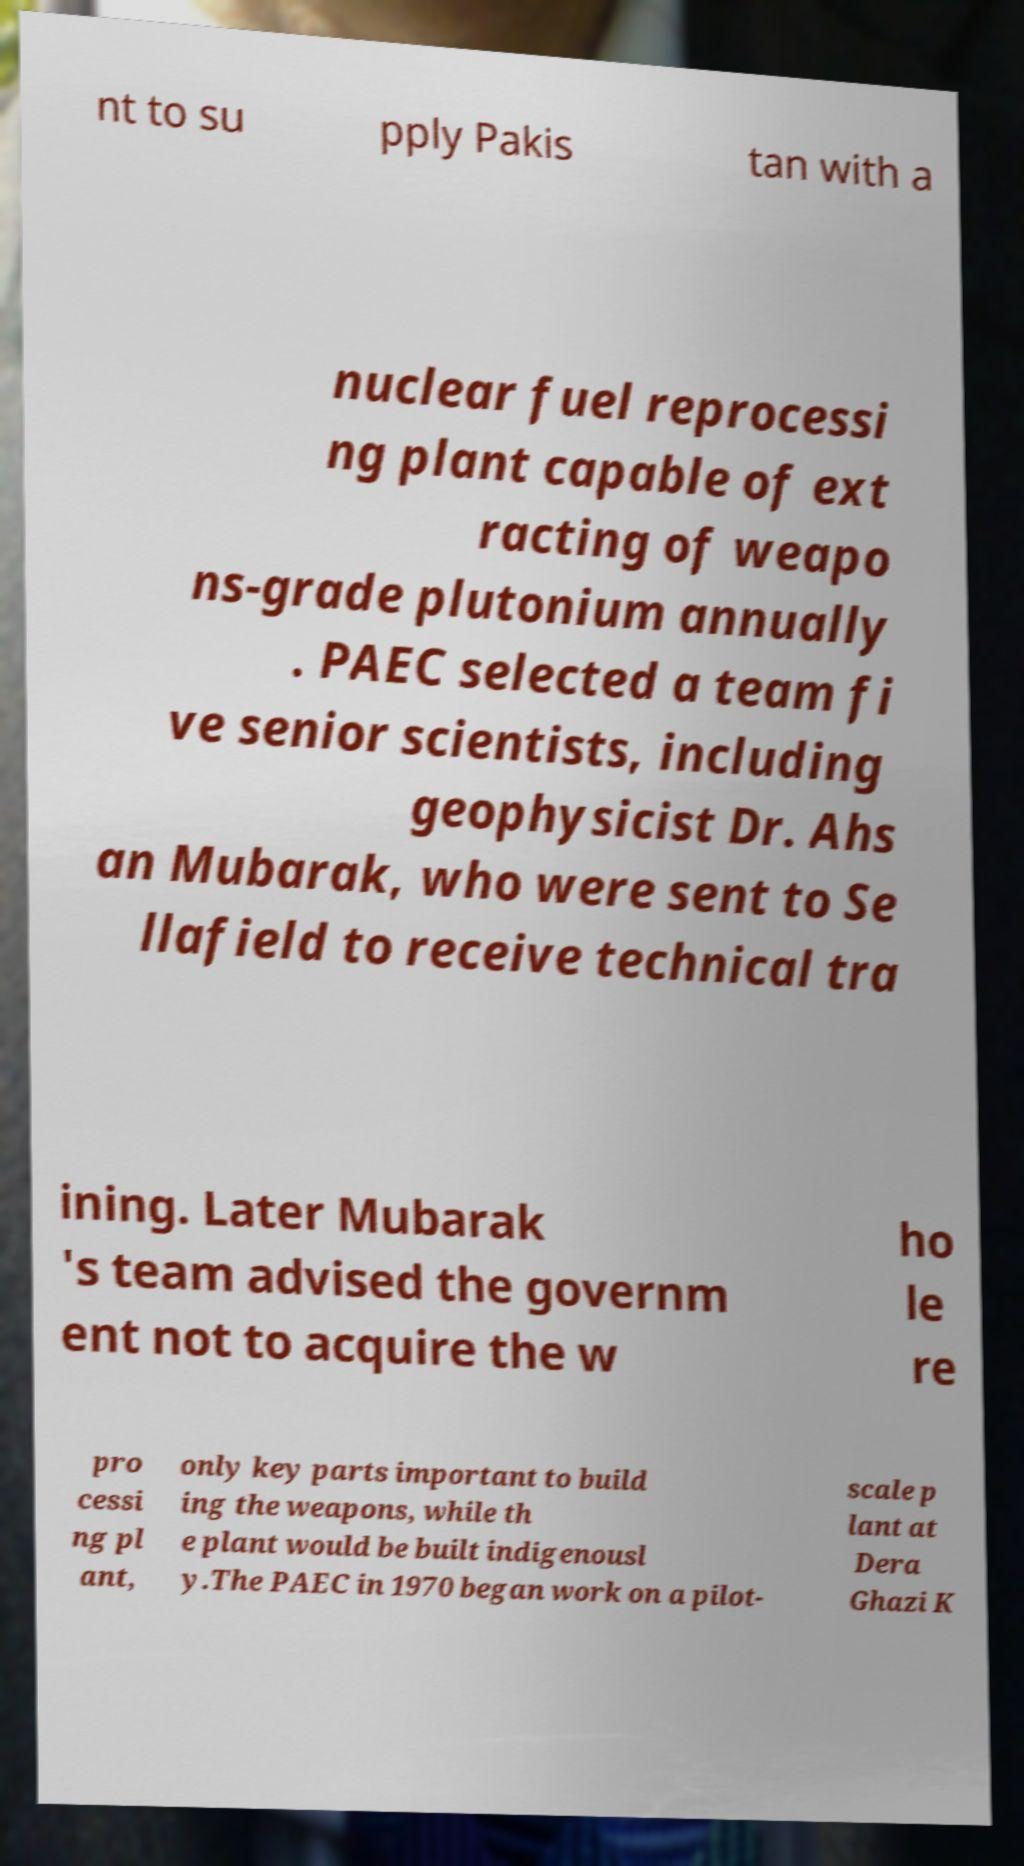What messages or text are displayed in this image? I need them in a readable, typed format. nt to su pply Pakis tan with a nuclear fuel reprocessi ng plant capable of ext racting of weapo ns-grade plutonium annually . PAEC selected a team fi ve senior scientists, including geophysicist Dr. Ahs an Mubarak, who were sent to Se llafield to receive technical tra ining. Later Mubarak 's team advised the governm ent not to acquire the w ho le re pro cessi ng pl ant, only key parts important to build ing the weapons, while th e plant would be built indigenousl y.The PAEC in 1970 began work on a pilot- scale p lant at Dera Ghazi K 